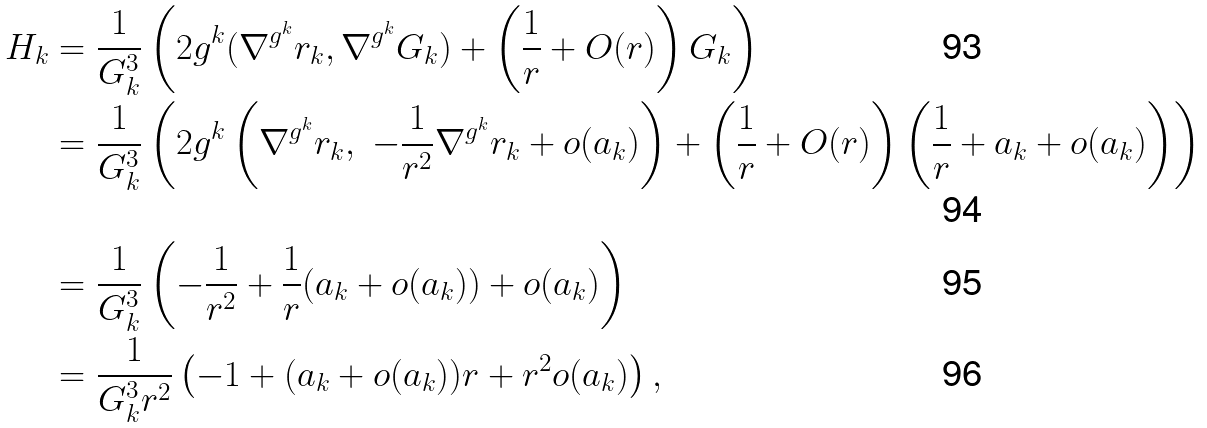<formula> <loc_0><loc_0><loc_500><loc_500>H _ { k } & = \frac { 1 } { G _ { k } ^ { 3 } } \left ( 2 g ^ { k } ( \nabla ^ { g ^ { k } } r _ { k } , \nabla ^ { g ^ { k } } G _ { k } ) + \left ( \frac { 1 } { r } + O ( r ) \right ) G _ { k } \right ) \\ & = \frac { 1 } { G _ { k } ^ { 3 } } \left ( 2 g ^ { k } \left ( \nabla ^ { g ^ { k } } r _ { k } , \ - \frac { 1 } { r ^ { 2 } } \nabla ^ { g ^ { k } } r _ { k } + o ( a _ { k } ) \right ) + \left ( \frac { 1 } { r } + O ( r ) \right ) \left ( \frac { 1 } { r } + a _ { k } + o ( a _ { k } ) \right ) \right ) \\ & = \frac { 1 } { G _ { k } ^ { 3 } } \left ( - \frac { 1 } { r ^ { 2 } } + \frac { 1 } { r } ( a _ { k } + o ( a _ { k } ) ) + o ( a _ { k } ) \right ) \\ & = \frac { 1 } { G _ { k } ^ { 3 } r ^ { 2 } } \left ( - 1 + ( a _ { k } + o ( a _ { k } ) ) r + r ^ { 2 } o ( a _ { k } ) \right ) ,</formula> 